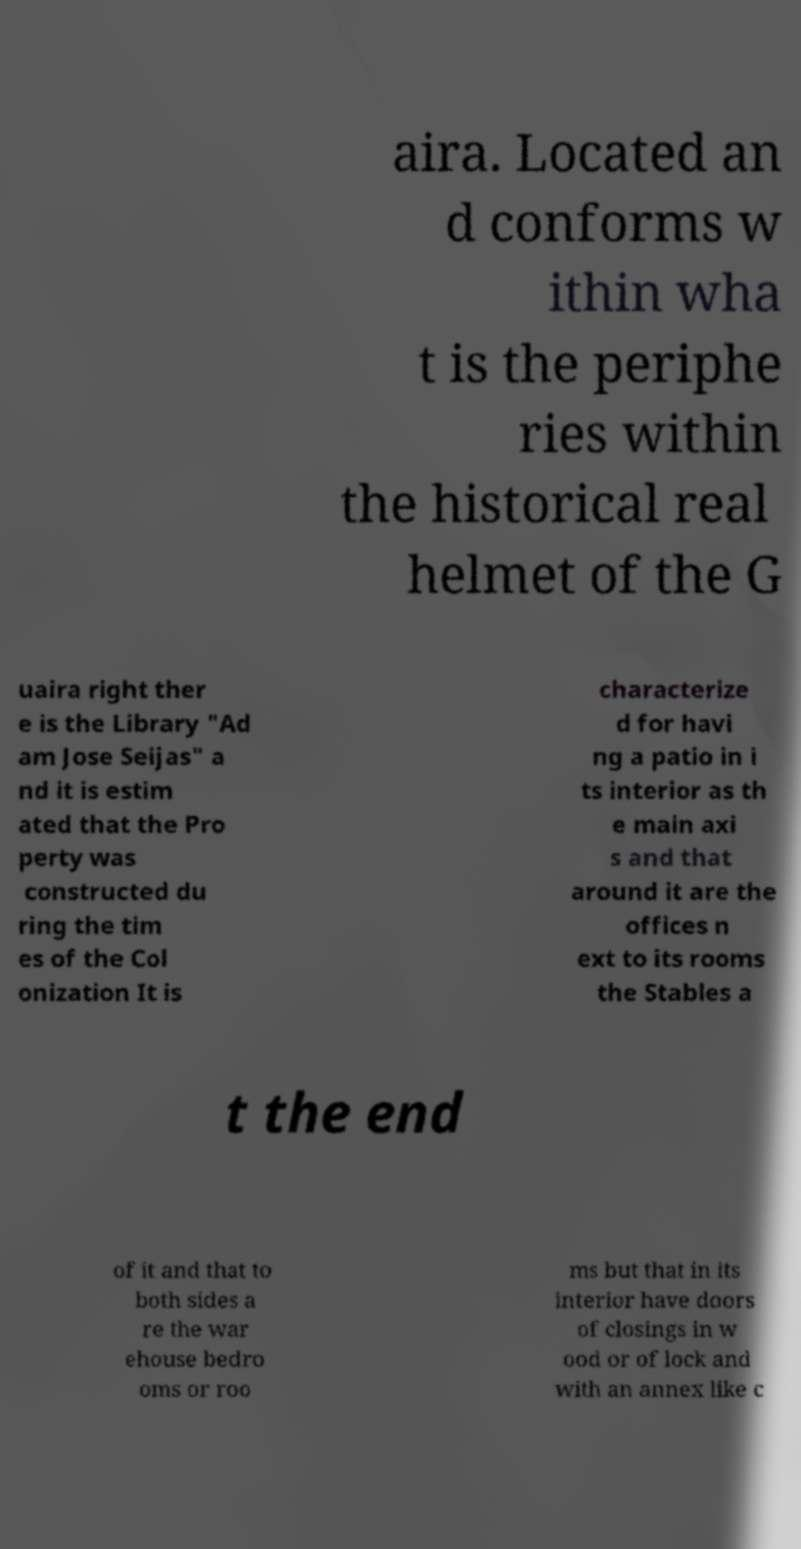I need the written content from this picture converted into text. Can you do that? aira. Located an d conforms w ithin wha t is the periphe ries within the historical real helmet of the G uaira right ther e is the Library "Ad am Jose Seijas" a nd it is estim ated that the Pro perty was constructed du ring the tim es of the Col onization It is characterize d for havi ng a patio in i ts interior as th e main axi s and that around it are the offices n ext to its rooms the Stables a t the end of it and that to both sides a re the war ehouse bedro oms or roo ms but that in its interior have doors of closings in w ood or of lock and with an annex like c 